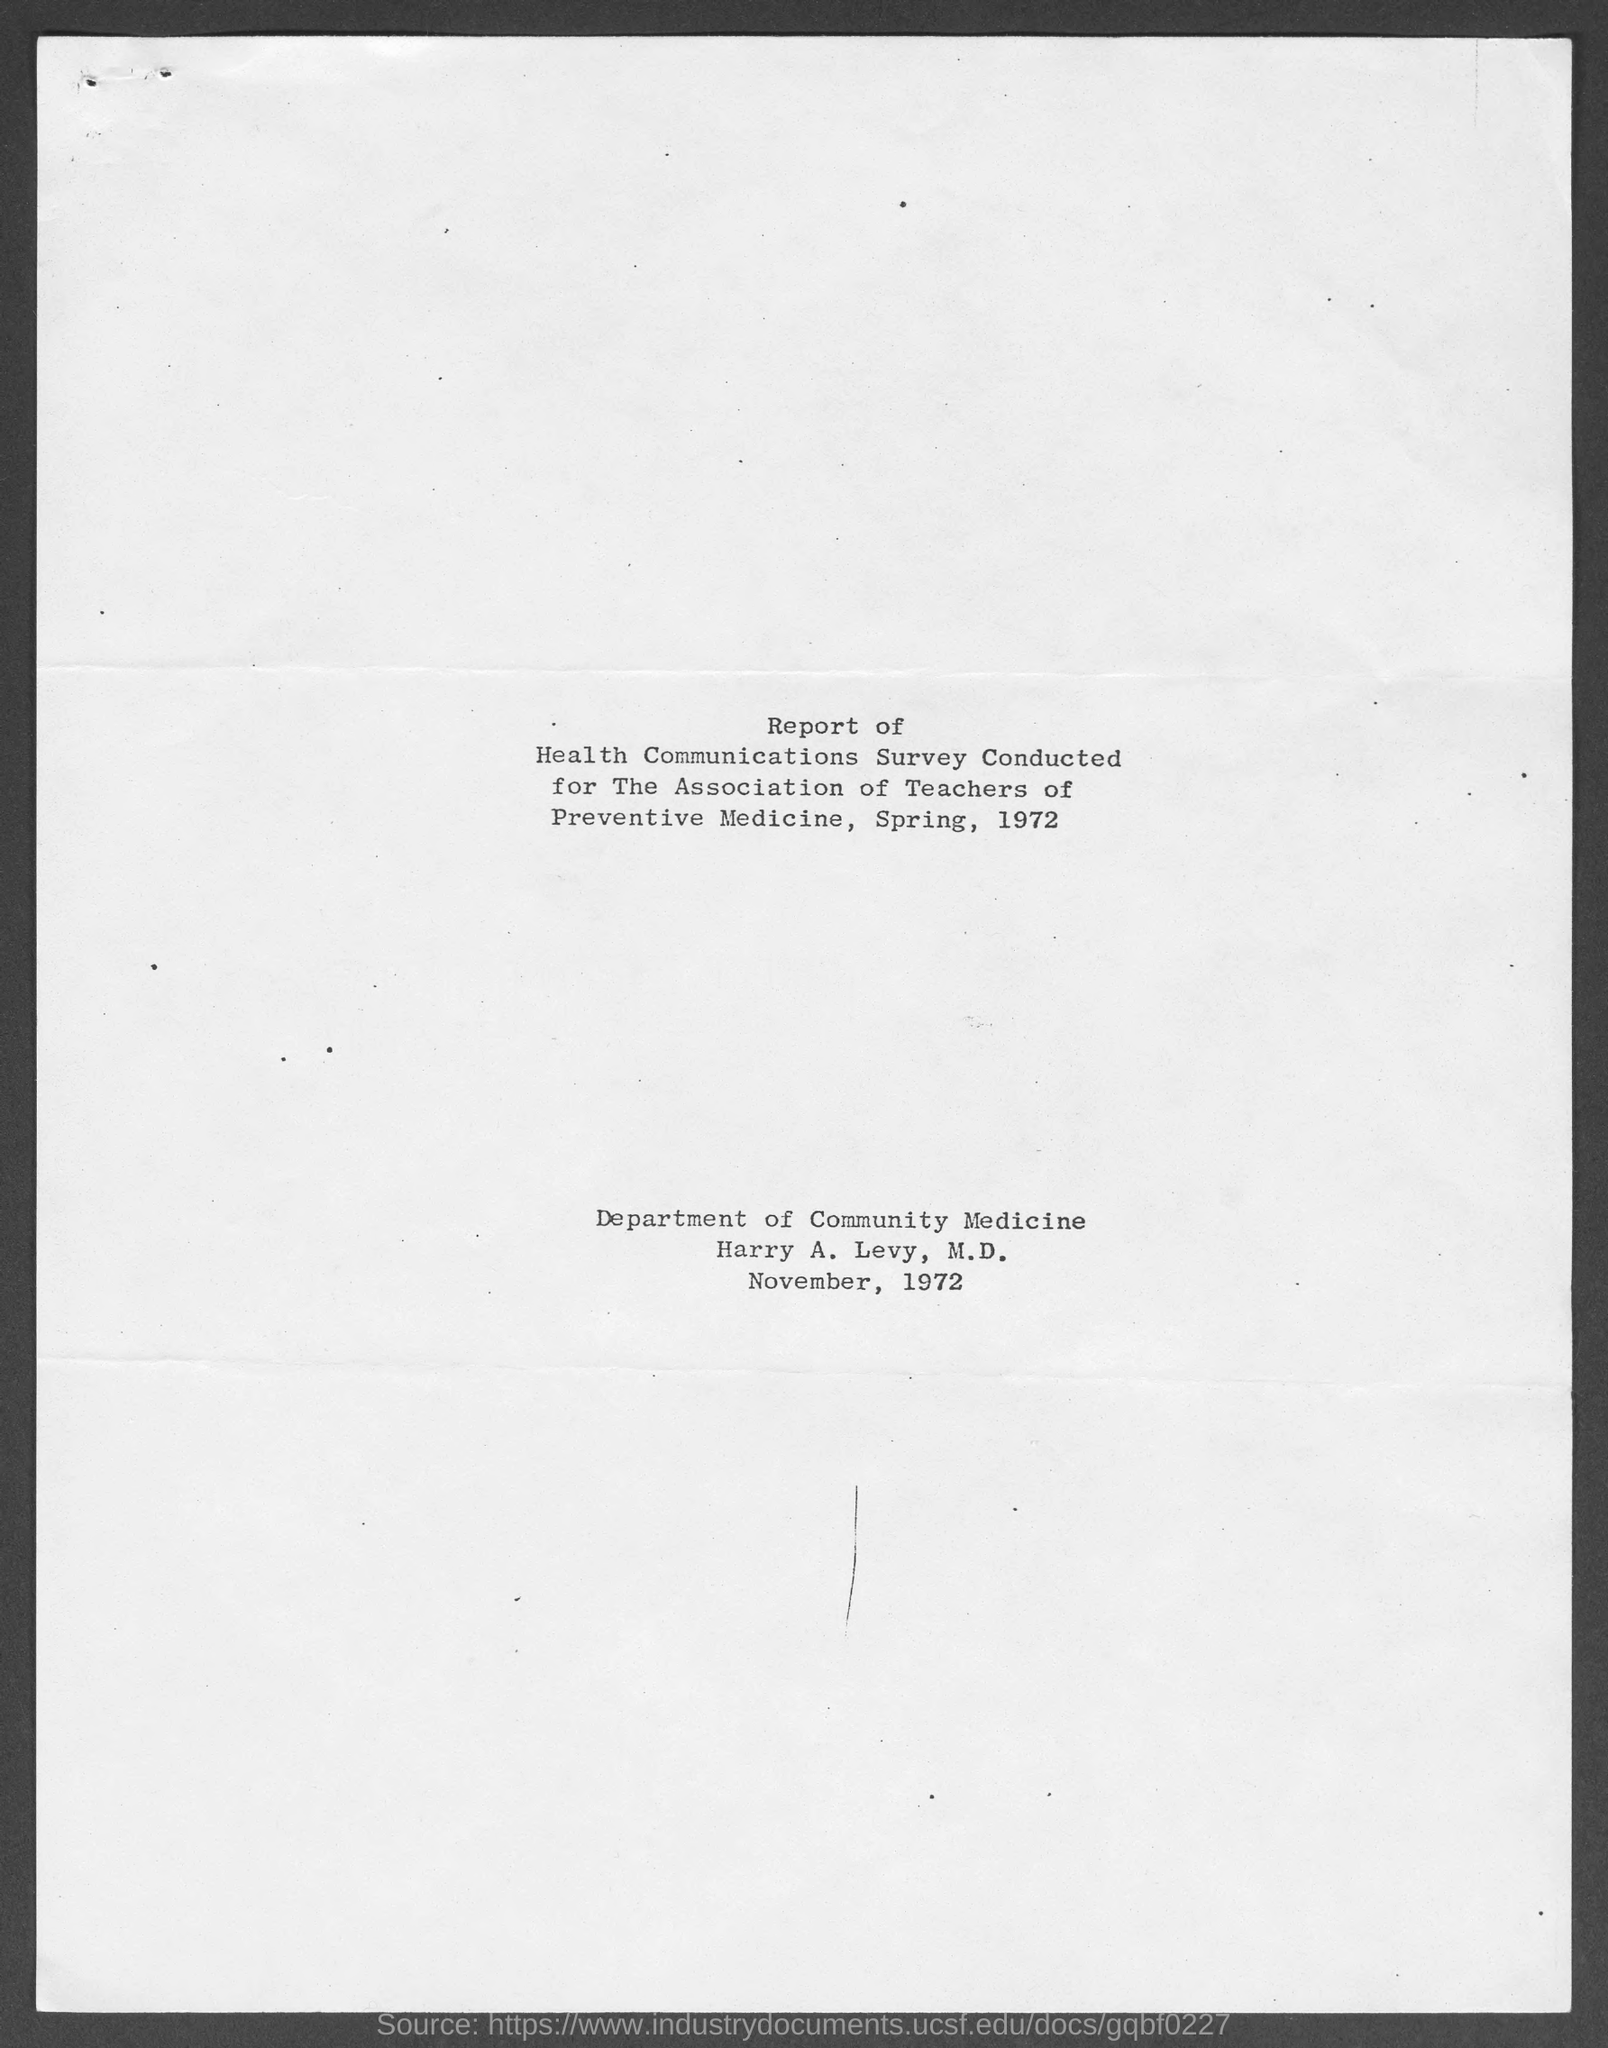Outline some significant characteristics in this image. The report was published in November 1972. The report was published by the Department of Community Medicine. The publication date of this report is 1972. 